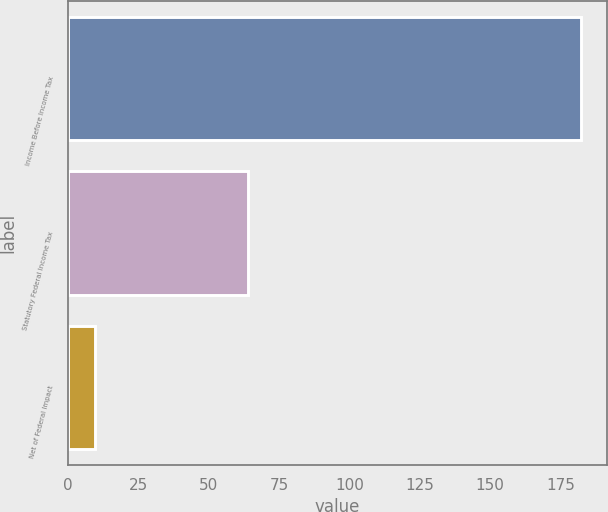<chart> <loc_0><loc_0><loc_500><loc_500><bar_chart><fcel>Income Before Income Tax<fcel>Statutory Federal Income Tax<fcel>Net of Federal Impact<nl><fcel>182.5<fcel>63.9<fcel>9.6<nl></chart> 